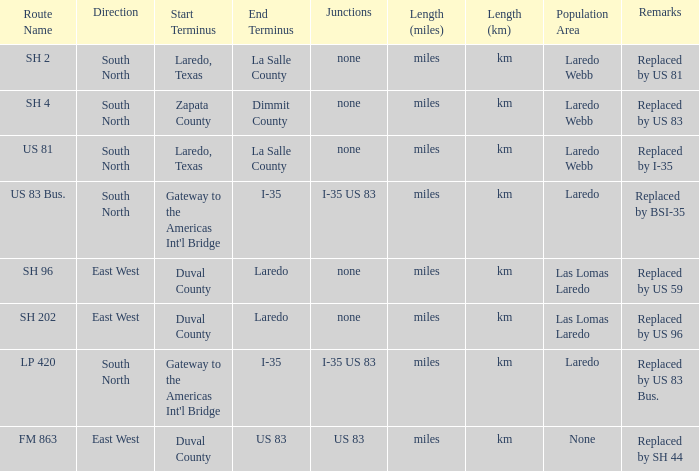How many termini are there that have "east west" listed in their direction section, "none" listed in their junction section, and have a route name of "sh 202"? 1.0. 